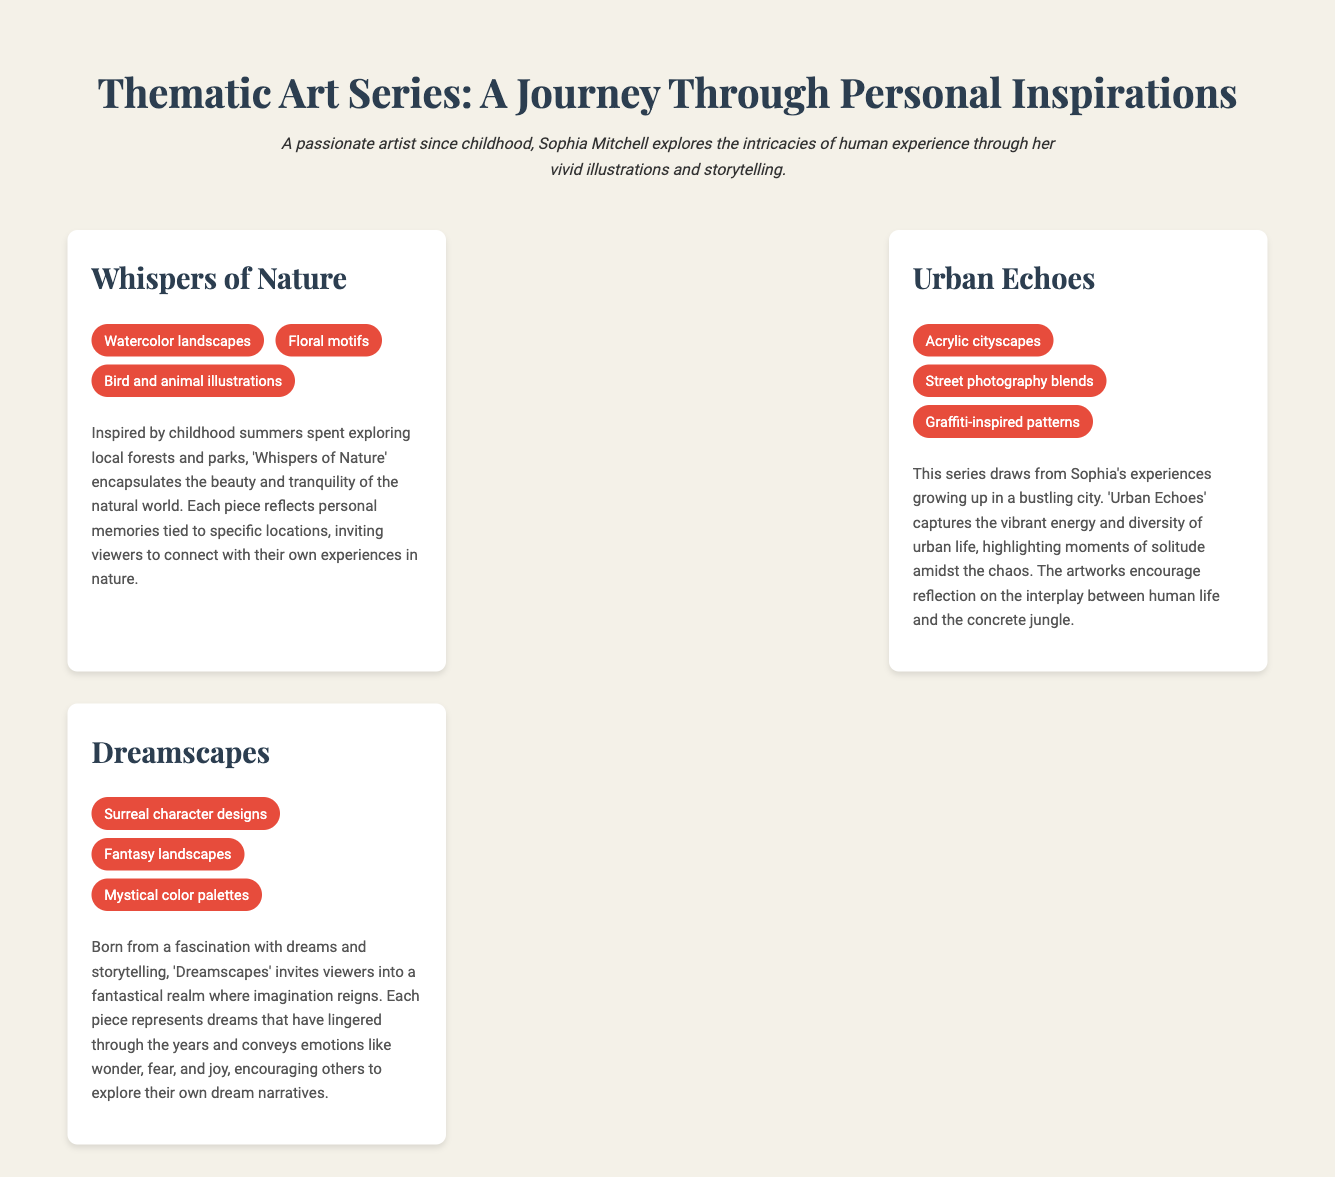What is the title of the catalog? The title appears in the document's header and summarizes the theme of the contents.
Answer: Thematic Art Series: A Journey Through Personal Inspirations Who is the artist featured in the catalog? The document mentions the artist's name prominently in the introduction area.
Answer: Sophia Mitchell What visual element is used in the "Whispers of Nature" series? The series includes a list of visual elements that define its artistic style.
Answer: Watercolor landscapes How many series are detailed in the document? The total number of series listed within the catalog is specified in the main content section.
Answer: Three What emotion is conveyed in the "Dreamscapes" series? The document outlines the feelings encouraged by the themes represented in each series.
Answer: Wonder What elements are combined in the "Urban Echoes" series? The artist blends different styles as stated in the visual elements section of this series.
Answer: Street photography blends Which series reflects childhood experiences in nature? The story behind each series gives insights into the artist's inspirations as mentioned in the document.
Answer: Whispers of Nature What artistic medium is used for "Dreamscapes"? The visual elements list provides insight into the techniques used in the artwork within this series.
Answer: Surreal character designs What thematic focus does "Urban Echoes" center on? The title and described story indicate the thematic basis of the series.
Answer: Urban life 